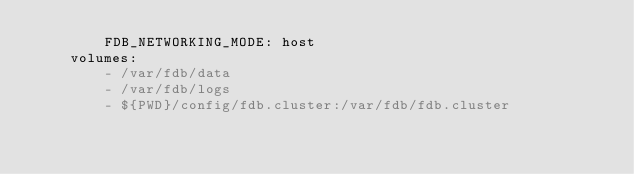Convert code to text. <code><loc_0><loc_0><loc_500><loc_500><_YAML_>        FDB_NETWORKING_MODE: host
    volumes:
        - /var/fdb/data
        - /var/fdb/logs
        - ${PWD}/config/fdb.cluster:/var/fdb/fdb.cluster
</code> 